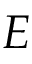<formula> <loc_0><loc_0><loc_500><loc_500>E</formula> 